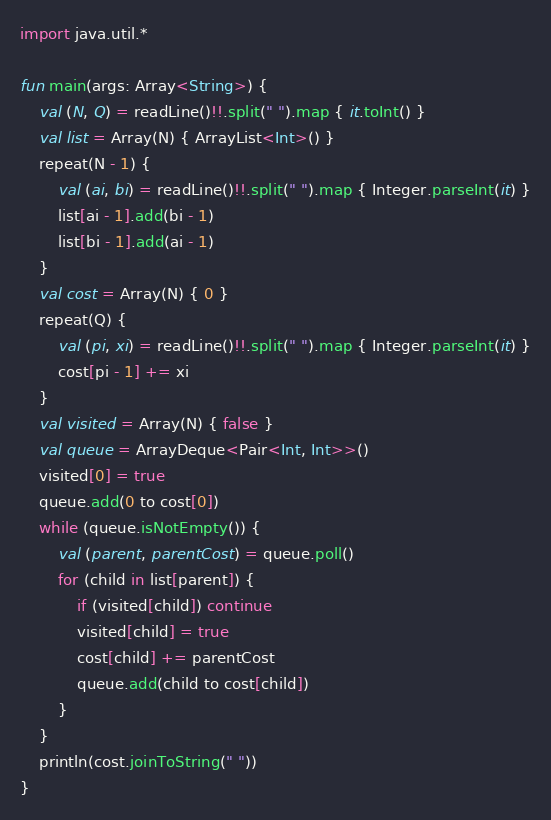<code> <loc_0><loc_0><loc_500><loc_500><_Kotlin_>import java.util.*

fun main(args: Array<String>) {
    val (N, Q) = readLine()!!.split(" ").map { it.toInt() }
    val list = Array(N) { ArrayList<Int>() }
    repeat(N - 1) {
        val (ai, bi) = readLine()!!.split(" ").map { Integer.parseInt(it) }
        list[ai - 1].add(bi - 1)
        list[bi - 1].add(ai - 1)
    }
    val cost = Array(N) { 0 }
    repeat(Q) {
        val (pi, xi) = readLine()!!.split(" ").map { Integer.parseInt(it) }
        cost[pi - 1] += xi
    }
    val visited = Array(N) { false }
    val queue = ArrayDeque<Pair<Int, Int>>()
    visited[0] = true
    queue.add(0 to cost[0])
    while (queue.isNotEmpty()) {
        val (parent, parentCost) = queue.poll()
        for (child in list[parent]) {
            if (visited[child]) continue
            visited[child] = true
            cost[child] += parentCost
            queue.add(child to cost[child])
        }
    }
    println(cost.joinToString(" "))
}</code> 